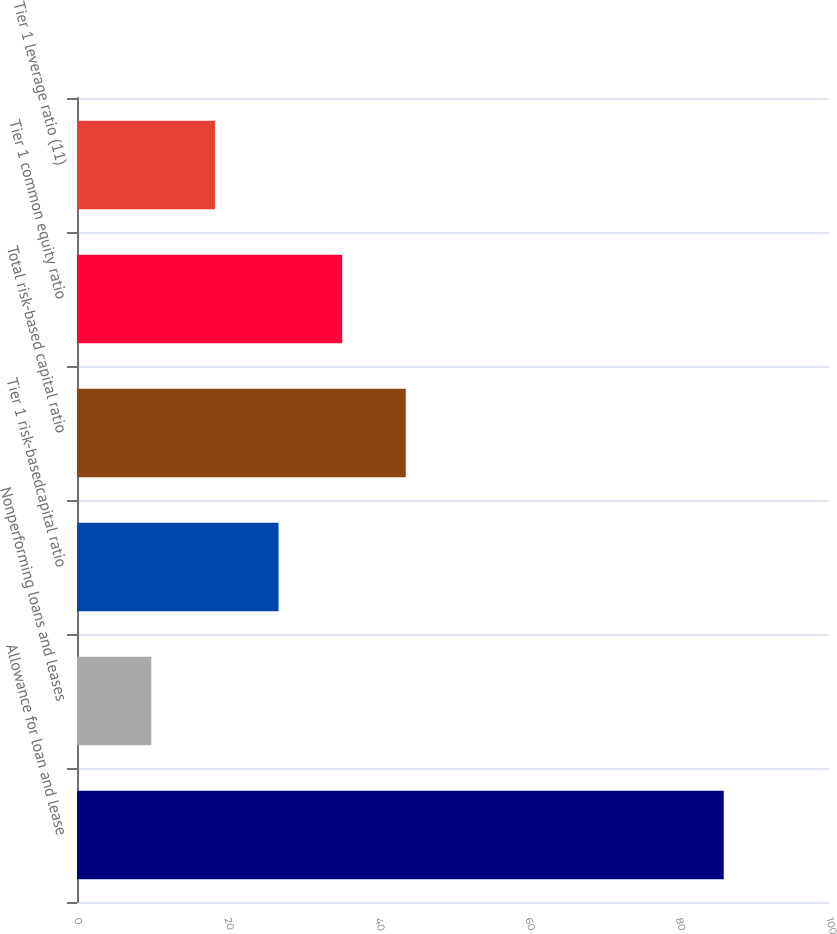Convert chart to OTSL. <chart><loc_0><loc_0><loc_500><loc_500><bar_chart><fcel>Allowance for loan and lease<fcel>Nonperforming loans and leases<fcel>Tier 1 risk-basedcapital ratio<fcel>Total risk-based capital ratio<fcel>Tier 1 common equity ratio<fcel>Tier 1 leverage ratio (11)<nl><fcel>86<fcel>9.88<fcel>26.8<fcel>43.72<fcel>35.26<fcel>18.34<nl></chart> 